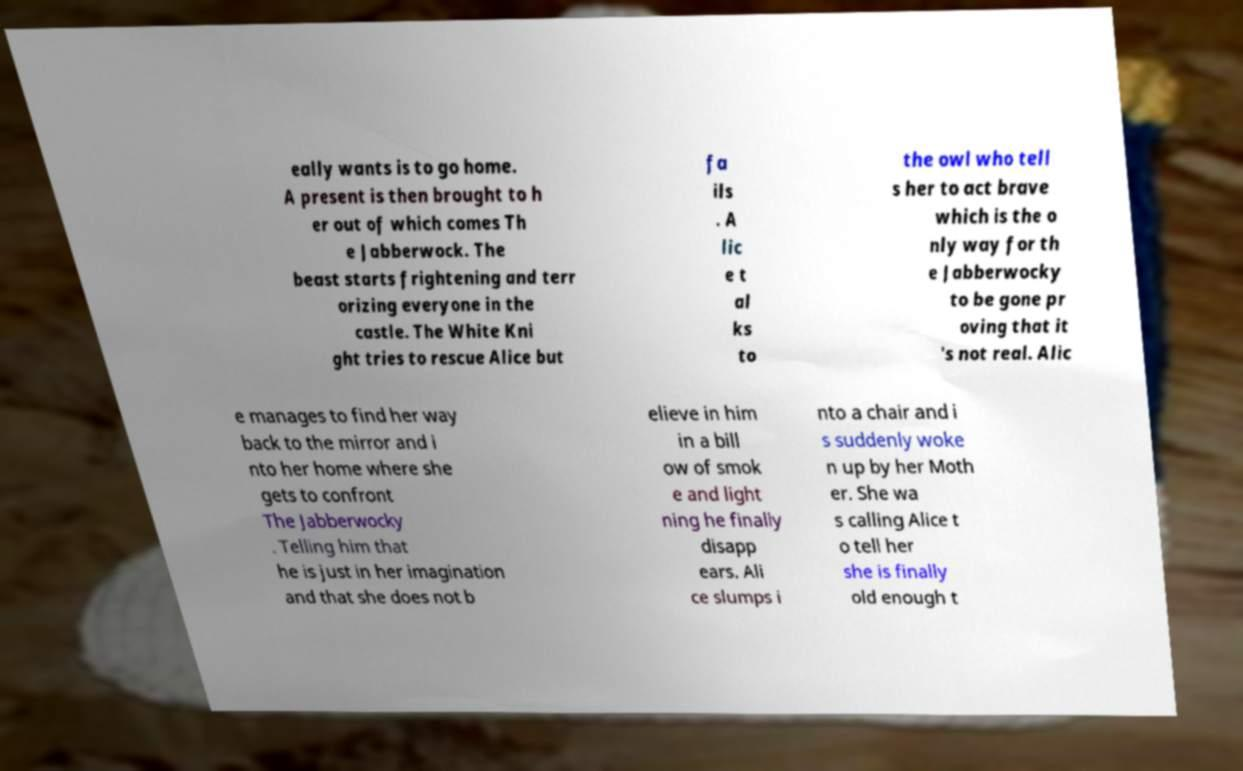Please read and relay the text visible in this image. What does it say? eally wants is to go home. A present is then brought to h er out of which comes Th e Jabberwock. The beast starts frightening and terr orizing everyone in the castle. The White Kni ght tries to rescue Alice but fa ils . A lic e t al ks to the owl who tell s her to act brave which is the o nly way for th e Jabberwocky to be gone pr oving that it 's not real. Alic e manages to find her way back to the mirror and i nto her home where she gets to confront The Jabberwocky . Telling him that he is just in her imagination and that she does not b elieve in him in a bill ow of smok e and light ning he finally disapp ears. Ali ce slumps i nto a chair and i s suddenly woke n up by her Moth er. She wa s calling Alice t o tell her she is finally old enough t 